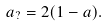<formula> <loc_0><loc_0><loc_500><loc_500>a _ { ? } = 2 ( 1 - a ) .</formula> 